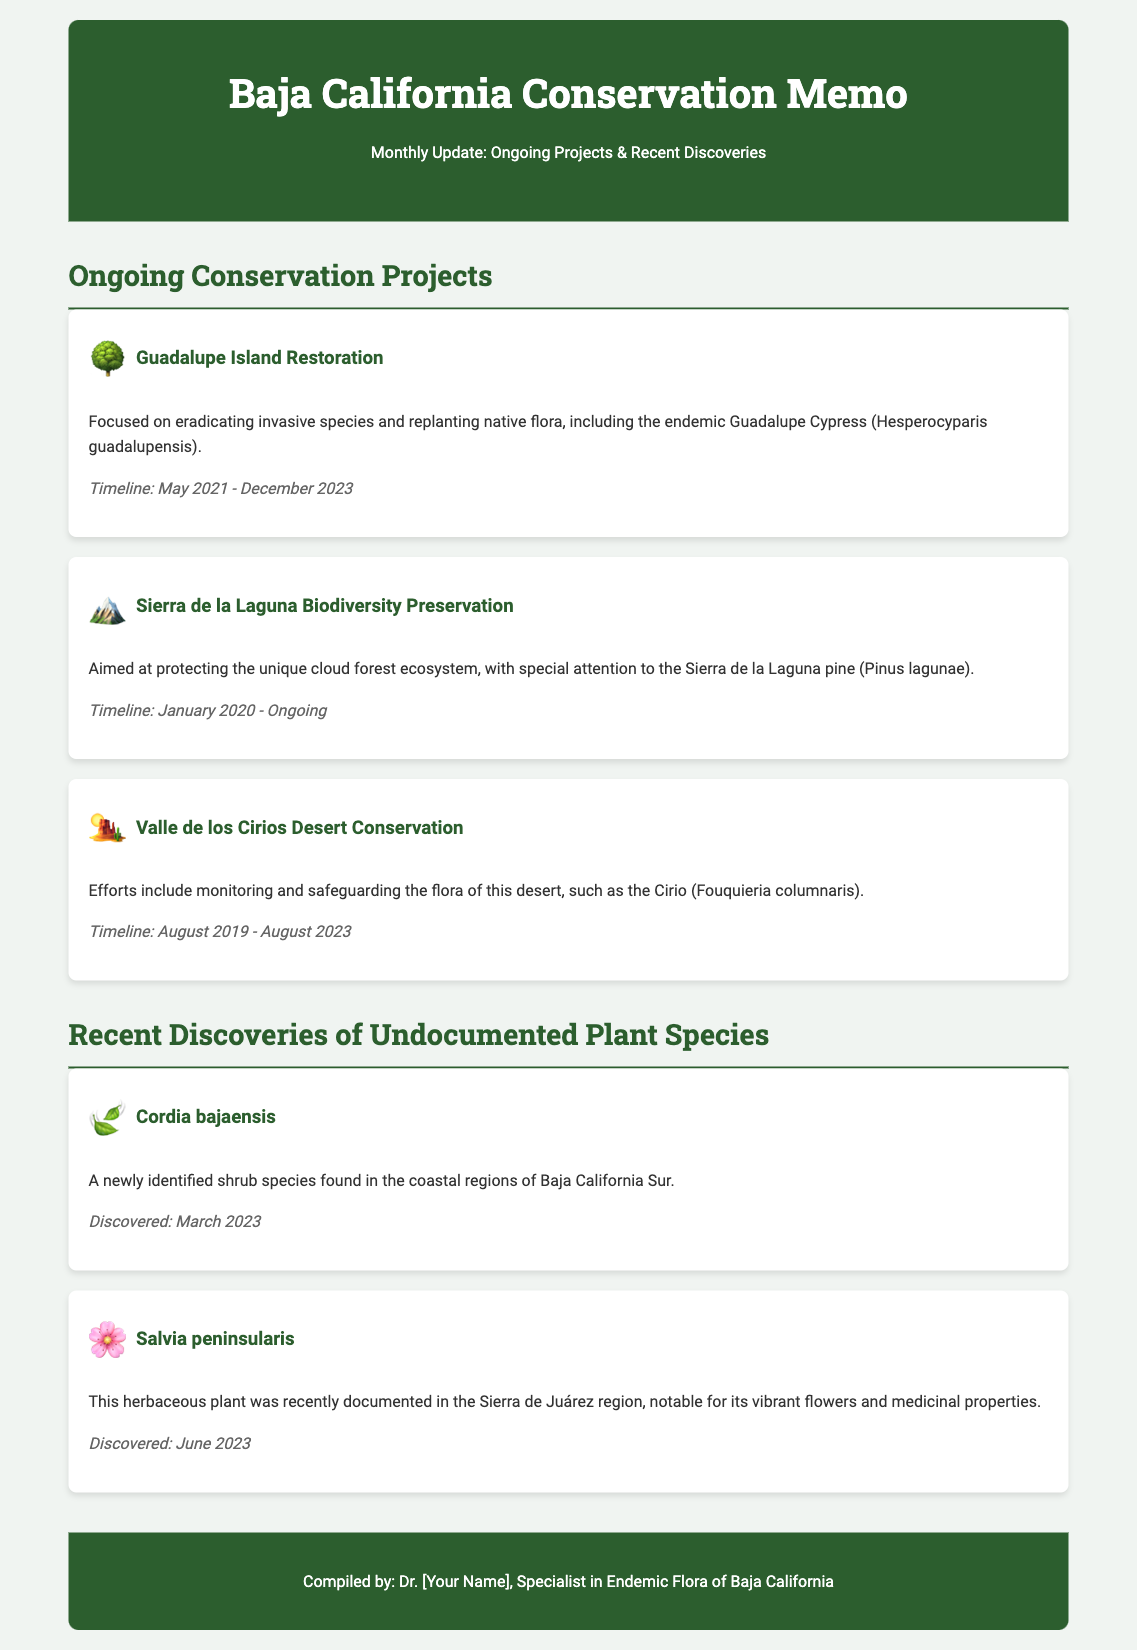what is the title of the memo? The title of the memo is given in the header section, which states "Baja California Conservation Memo".
Answer: Baja California Conservation Memo who compiled the document? The document is compiled by Dr. [Your Name], whose field of expertise is mentioned as "Specialist in Endemic Flora of Baja California".
Answer: Dr. [Your Name] what is the focus of the Guadalupe Island Restoration project? The project focuses on eradicating invasive species and replanting native flora, highlighted by the mention of the endemic Guadalupe Cypress.
Answer: Eradicating invasive species and replanting native flora when was the Cordia bajaensis species discovered? The date of discovery is noted in the "Recent Discoveries" section, specifically indicating "March 2023".
Answer: March 2023 how long is the timeline for the Valle de los Cirios Desert Conservation project? The timeline duration is provided as "August 2019 - August 2023", which gives an overall duration of four years.
Answer: August 2019 - August 2023 which plant is known for its vibrant flowers and medicinal properties? The plant is specified in the document as Salvia peninsularis, mentioned along with its distinctive characteristics.
Answer: Salvia peninsularis what emoji represents the Sierra de la Laguna Biodiversity Preservation project? The project section shows an emoji next to its title, which is a mountain emoji representing the Sierra de la Laguna project.
Answer: 🏔️ how many ongoing conservation projects are listed? The document lists three ongoing conservation projects in the section titled "Ongoing Conservation Projects".
Answer: Three 